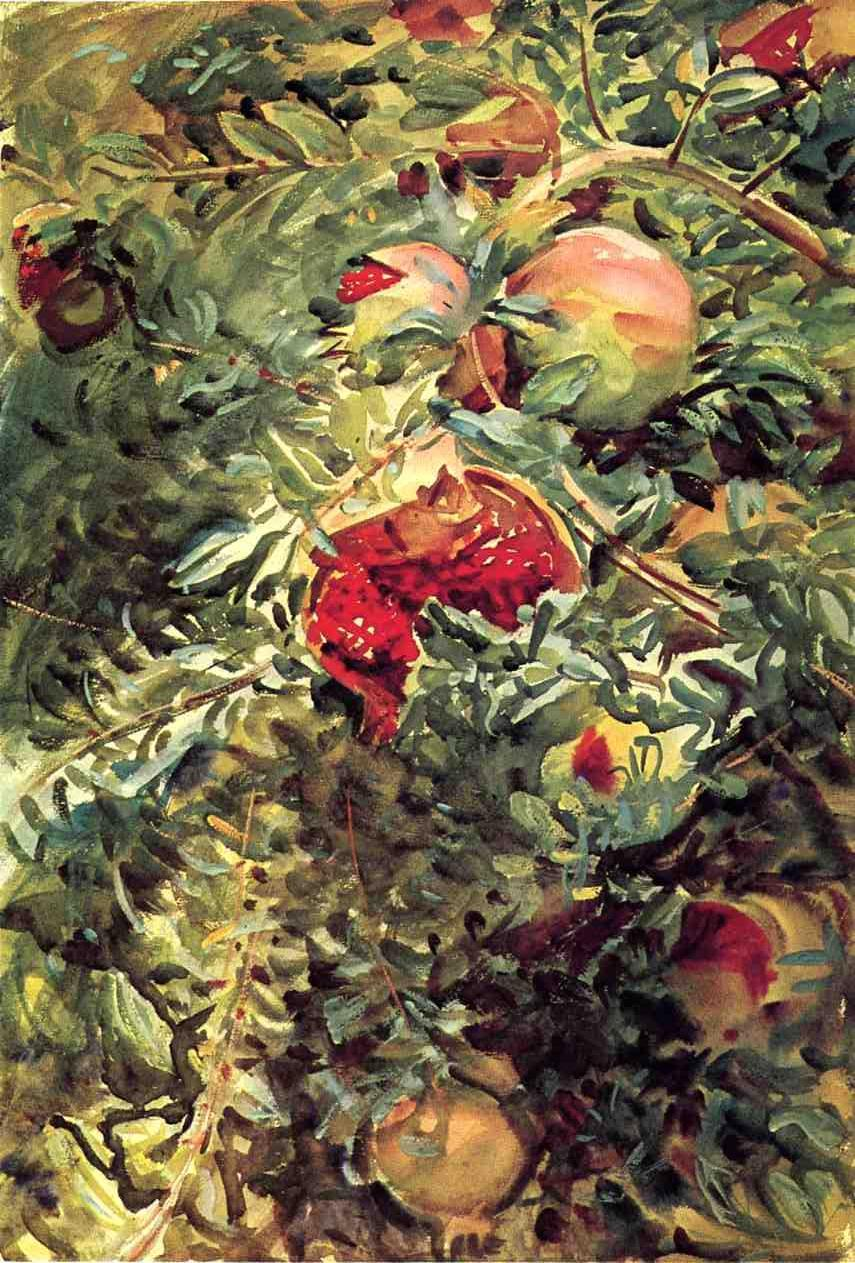Describe the following image. The image depicts a lush fruit tree portrayed in the impressionistic style, characterized by vivid, swirling brushstrokes that blend the colors of the leaves and fruits seamlessly. The color palette is rich, with shades of green, red, and orange creating a dynamic and almost tactile texture. The fruits, possibly apples and strawberries, are not meticulously detailed but suggested through bursts of color and form, evoking a sense of abundance and natural growth. This painting likely aims to capture more than the physical appearance of the tree, attempting to convey the vibrancy and fleeting beauty of nature. 